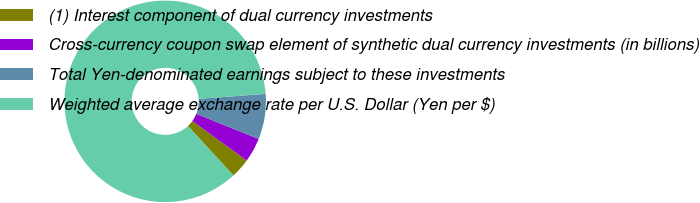Convert chart to OTSL. <chart><loc_0><loc_0><loc_500><loc_500><pie_chart><fcel>(1) Interest component of dual currency investments<fcel>Cross-currency coupon swap element of synthetic dual currency investments (in billions)<fcel>Total Yen-denominated earnings subject to these investments<fcel>Weighted average exchange rate per U.S. Dollar (Yen per $)<nl><fcel>3.16%<fcel>3.91%<fcel>7.27%<fcel>85.66%<nl></chart> 